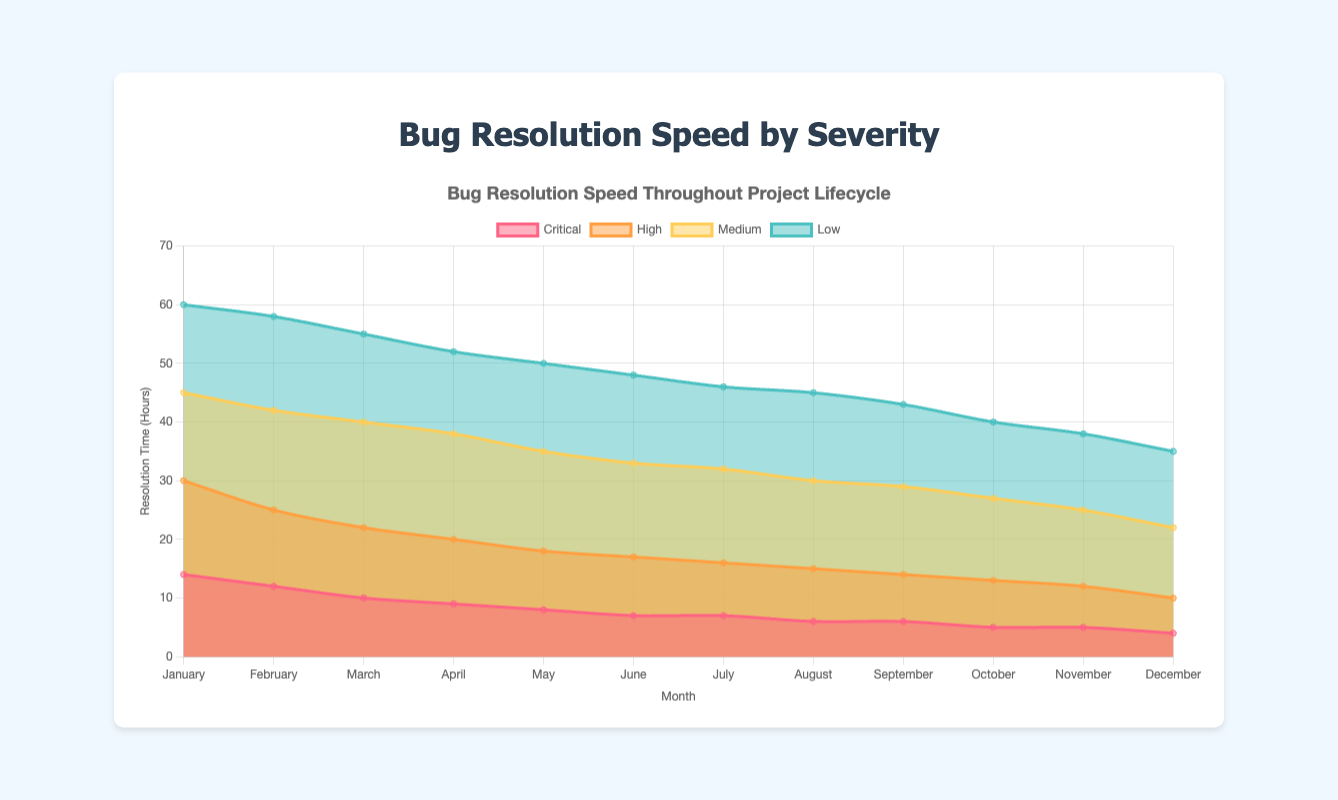What's the title of the chart? The title is located at the top of the chart and it reads "Bug Resolution Speed by Severity".
Answer: Bug Resolution Speed by Severity How many severity categories are represented in the chart? There are four different colored areas within the chart, each representing a different severity category: Critical, High, Medium, and Low.
Answer: Four Which month has the fastest bug resolution time for critical issues? By examining the "Critical" category in the chart, January has the highest value, indicating it has the fastest resolution time as it decreases over the year.
Answer: December What is the resolution time for medium severity bugs in April? Look at the "Medium" category for the month of April; the number associated with April is the resolution time, which is 38 hours.
Answer: 38 Which severity category shows the most significant decrease in resolution time from January to December? Compare the difference in resolution times from January to December for each category. The "Low" category shows the largest drop from 60 hours in January to 35 hours in December.
Answer: Low How does the resolution speed for high severity bugs change throughout the year? Observe the "High" category line from January to December; it shows a consistent decrease from 30 hours in January to 10 hours in December.
Answer: Decreases In which month is the gap between high and medium resolution speeds the smallest? By comparing the values for "High" and "Medium" categories across all months, the smallest gap occurs in December where "High" is 10 hours, and "Medium" is 22 hours, making the gap 12 hours.
Answer: December By how much does the resolution time for critical issues decrease from January to June? Subtract the resolution time in June from that in January for the "Critical" category: 14 - 7 = 7 hours.
Answer: 7 hours Which category’s resolution time remains the most stable throughout the year? Check the range of fluctuation for each severity category. The "Critical" category remains the most stable, varying only from 14 to 4 hours.
Answer: Critical 